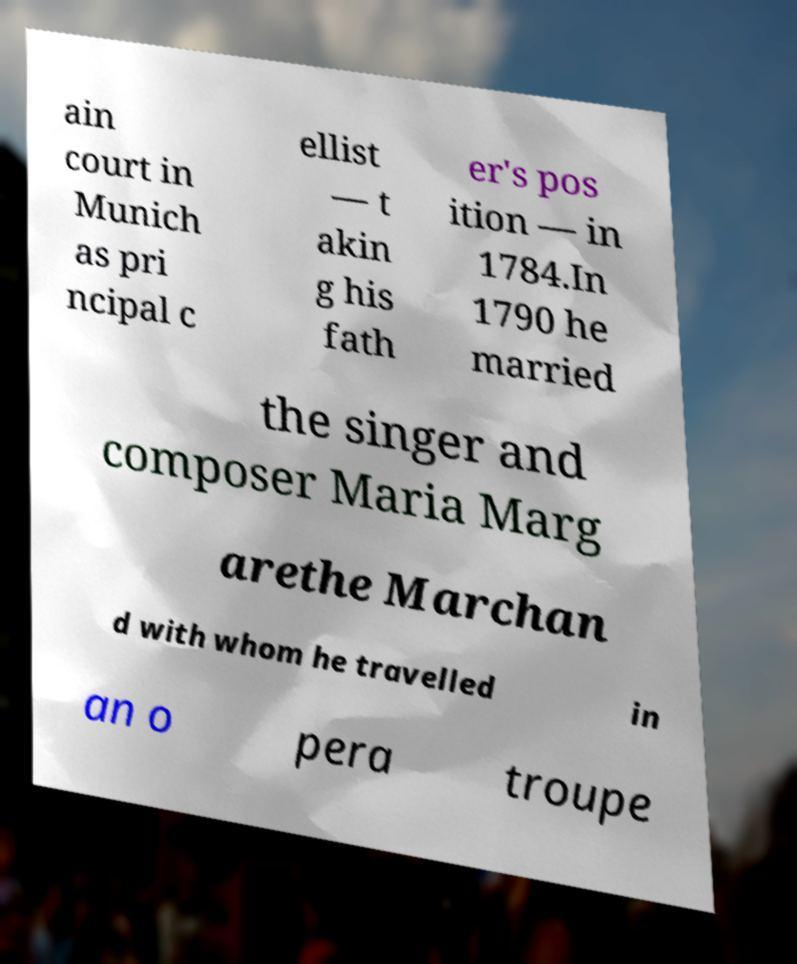Please read and relay the text visible in this image. What does it say? ain court in Munich as pri ncipal c ellist — t akin g his fath er's pos ition — in 1784.In 1790 he married the singer and composer Maria Marg arethe Marchan d with whom he travelled in an o pera troupe 